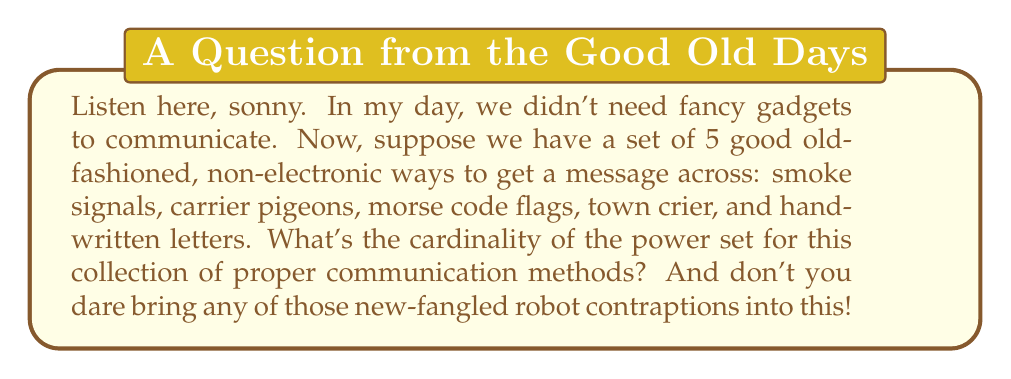Can you solve this math problem? Alright, let's break this down step by step, without any of that modern nonsense:

1) First, we need to understand what a power set is. The power set of a set S is the set of all subsets of S, including the empty set and S itself.

2) We have 5 elements in our original set. Let's call this set A:
   $A = \{\text{smoke signals, carrier pigeons, morse code flags, town crier, handwritten letters}\}$

3) Now, to find the cardinality (size) of the power set, we use the formula:
   $|P(A)| = 2^n$
   Where n is the number of elements in the original set A.

4) In this case, $n = 5$

5) So, we calculate:
   $|P(A)| = 2^5 = 32$

6) To understand why this works, consider that for each element in the original set, we have two choices: include it in a subset or not. With 5 elements, we have 2 choices for each of the 5 positions, giving us $2 \times 2 \times 2 \times 2 \times 2 = 2^5 = 32$ possible combinations.

7) These 32 subsets include:
   - The empty set $\{\}$
   - 5 subsets with one element each
   - 10 subsets with two elements each
   - 10 subsets with three elements each
   - 5 subsets with four elements each
   - The full set A itself

So, there you have it. No need for any of those confounded electronic calculators or robot helpers.
Answer: $|P(A)| = 2^5 = 32$ 